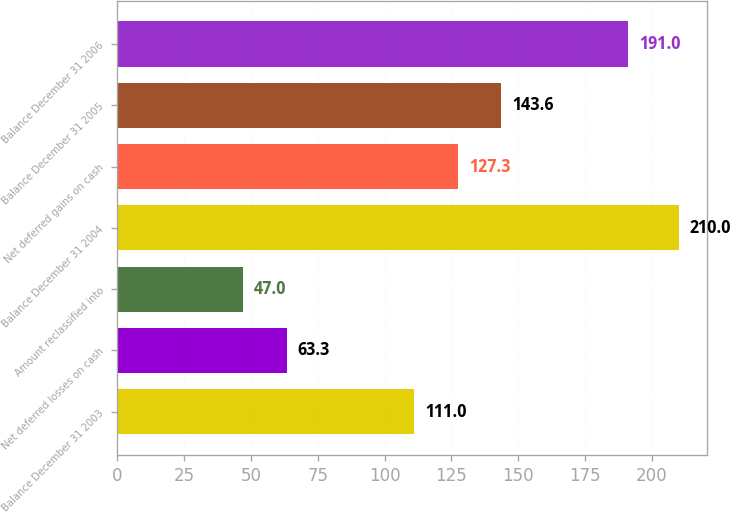Convert chart to OTSL. <chart><loc_0><loc_0><loc_500><loc_500><bar_chart><fcel>Balance December 31 2003<fcel>Net deferred losses on cash<fcel>Amount reclassified into<fcel>Balance December 31 2004<fcel>Net deferred gains on cash<fcel>Balance December 31 2005<fcel>Balance December 31 2006<nl><fcel>111<fcel>63.3<fcel>47<fcel>210<fcel>127.3<fcel>143.6<fcel>191<nl></chart> 